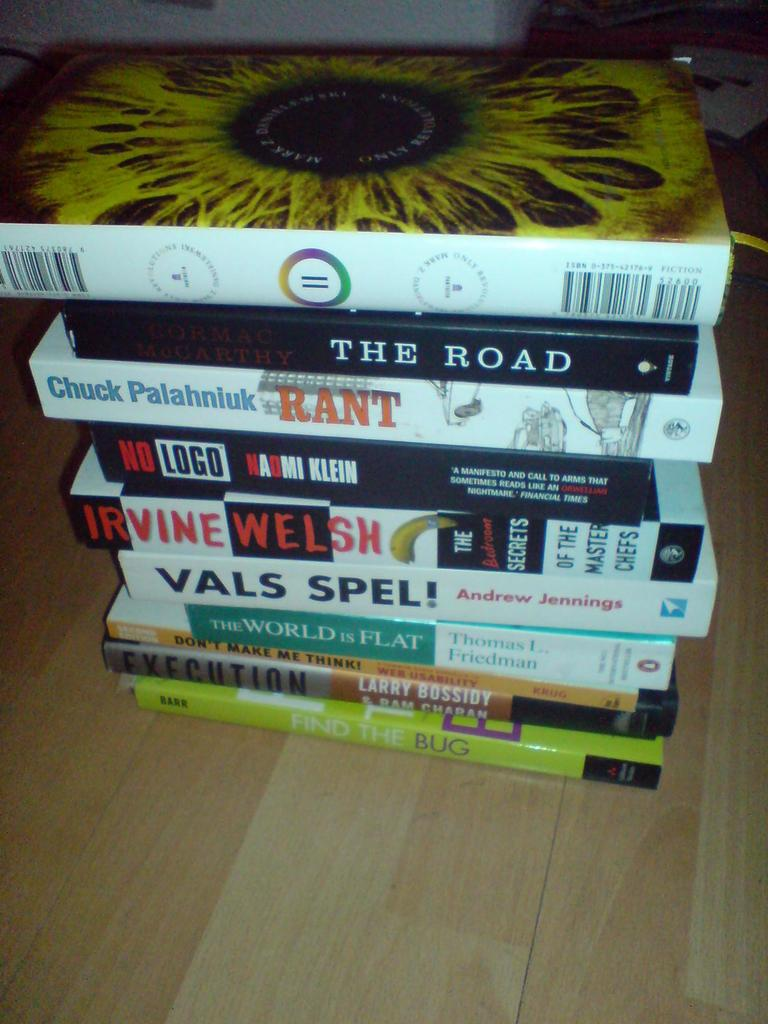Provide a one-sentence caption for the provided image. Books are stacked in a pile, the one on the bottom is titled Find the Bug. 